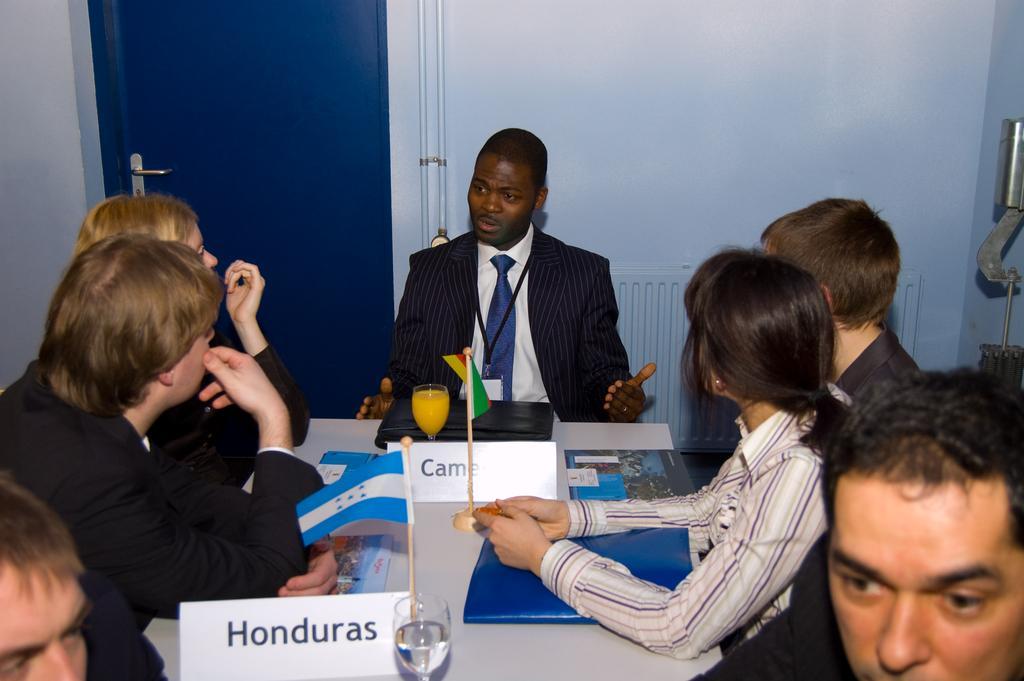Please provide a concise description of this image. In this image there are people sitting on the chairs. In front of them there is a table. On top of it there are name boards. There are glasses, files. In the background of the image there is a closed door. There is a wall. On the right side of the image there is some metal object. 